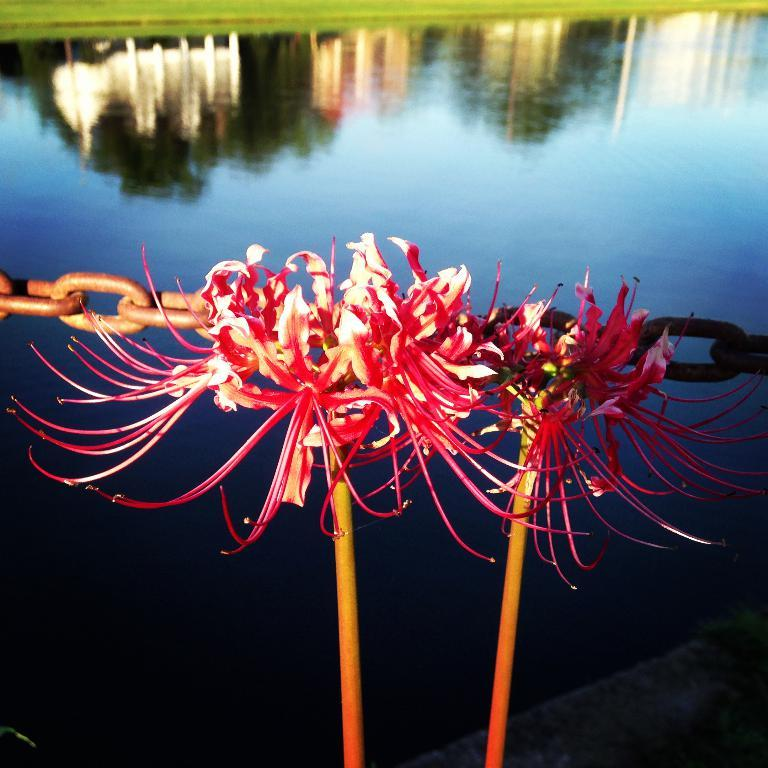What type of plants can be seen in the image? There are flowering plants in the image. What material is the chain made of? The chain in the image is made of metal. What can be seen in the background of the image? There is water visible in the image. What type of vegetation is present in the image? There is grass in the image. What might be the location of the image based on the visible elements? The image may have been taken near a lake, given the presence of water and grass. What team: Can you tell me how many members of the team are visible in the image? There is no team or team members present in the image. ear: What type of ear is visible in the image? There are no ears present in the image. 